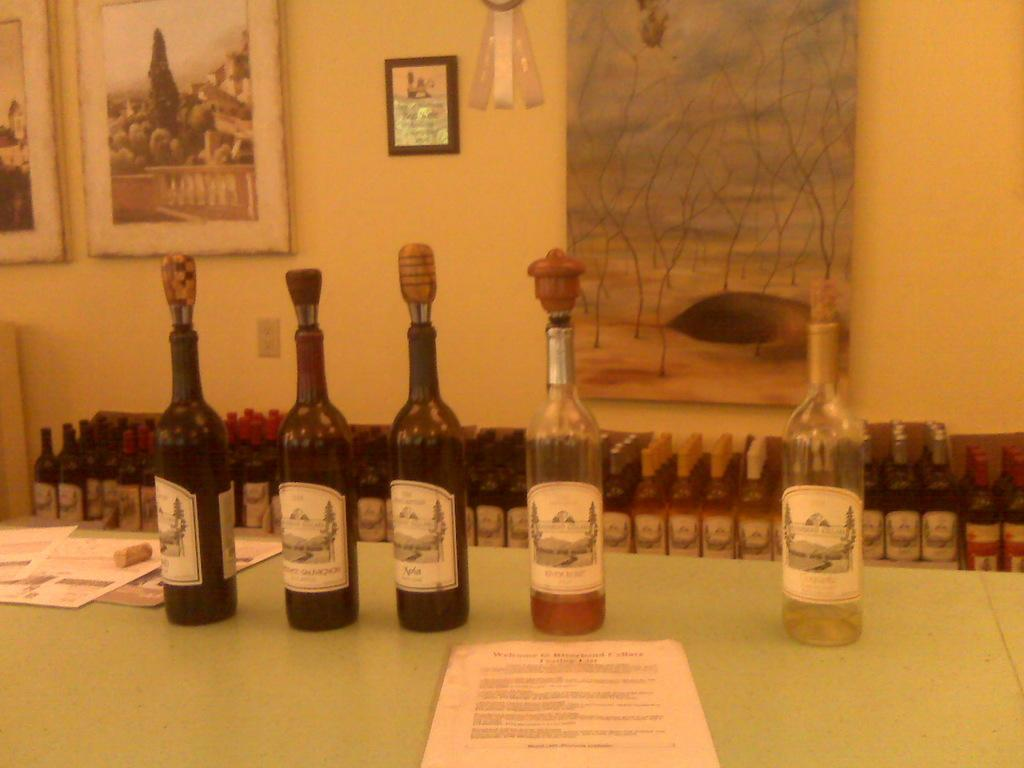<image>
Offer a succinct explanation of the picture presented. several bottles of wine are opened behind a welcome paper on a table 